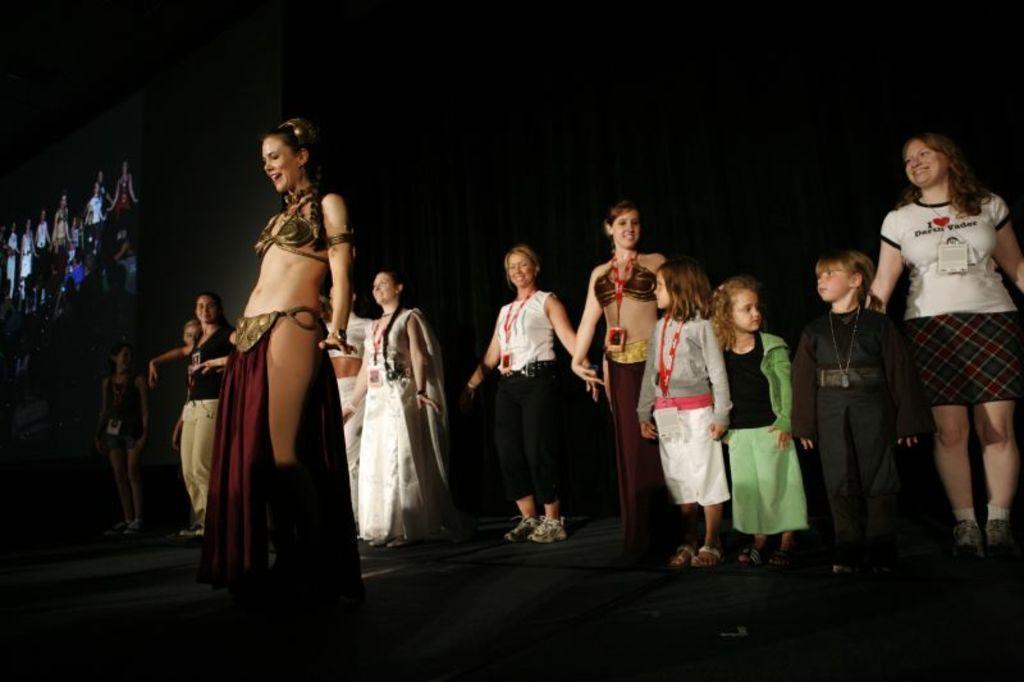In one or two sentences, can you explain what this image depicts? In this image we can see group of people standing on the ground. Three children are wearing different costumes. One girl is wearing a green dress. One boy is wearing a id card. In the background, we can see a screen and a black cloth. 